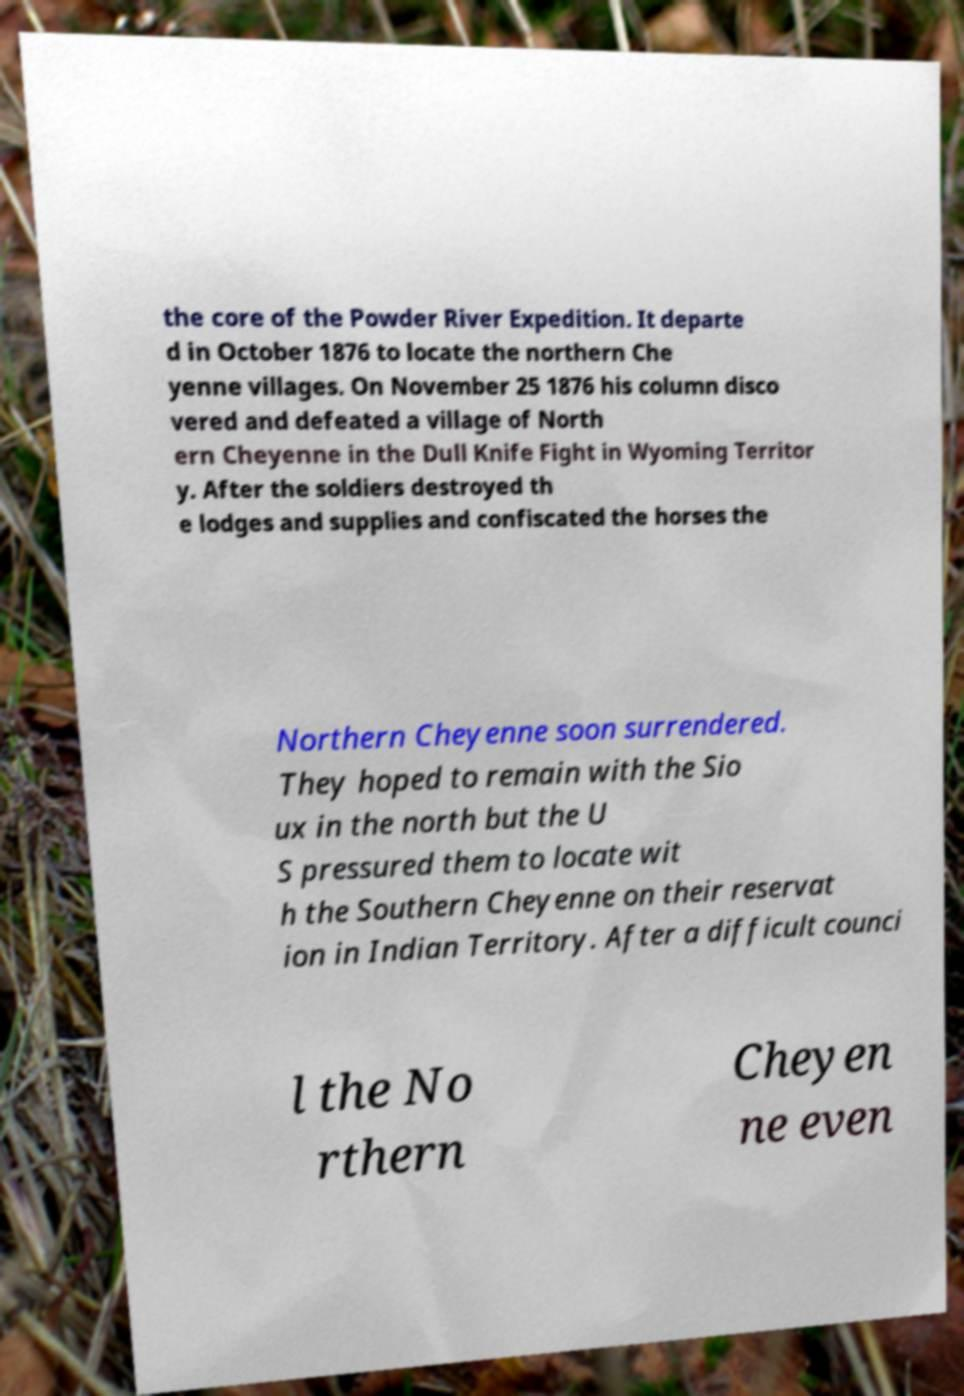Please read and relay the text visible in this image. What does it say? the core of the Powder River Expedition. It departe d in October 1876 to locate the northern Che yenne villages. On November 25 1876 his column disco vered and defeated a village of North ern Cheyenne in the Dull Knife Fight in Wyoming Territor y. After the soldiers destroyed th e lodges and supplies and confiscated the horses the Northern Cheyenne soon surrendered. They hoped to remain with the Sio ux in the north but the U S pressured them to locate wit h the Southern Cheyenne on their reservat ion in Indian Territory. After a difficult counci l the No rthern Cheyen ne even 